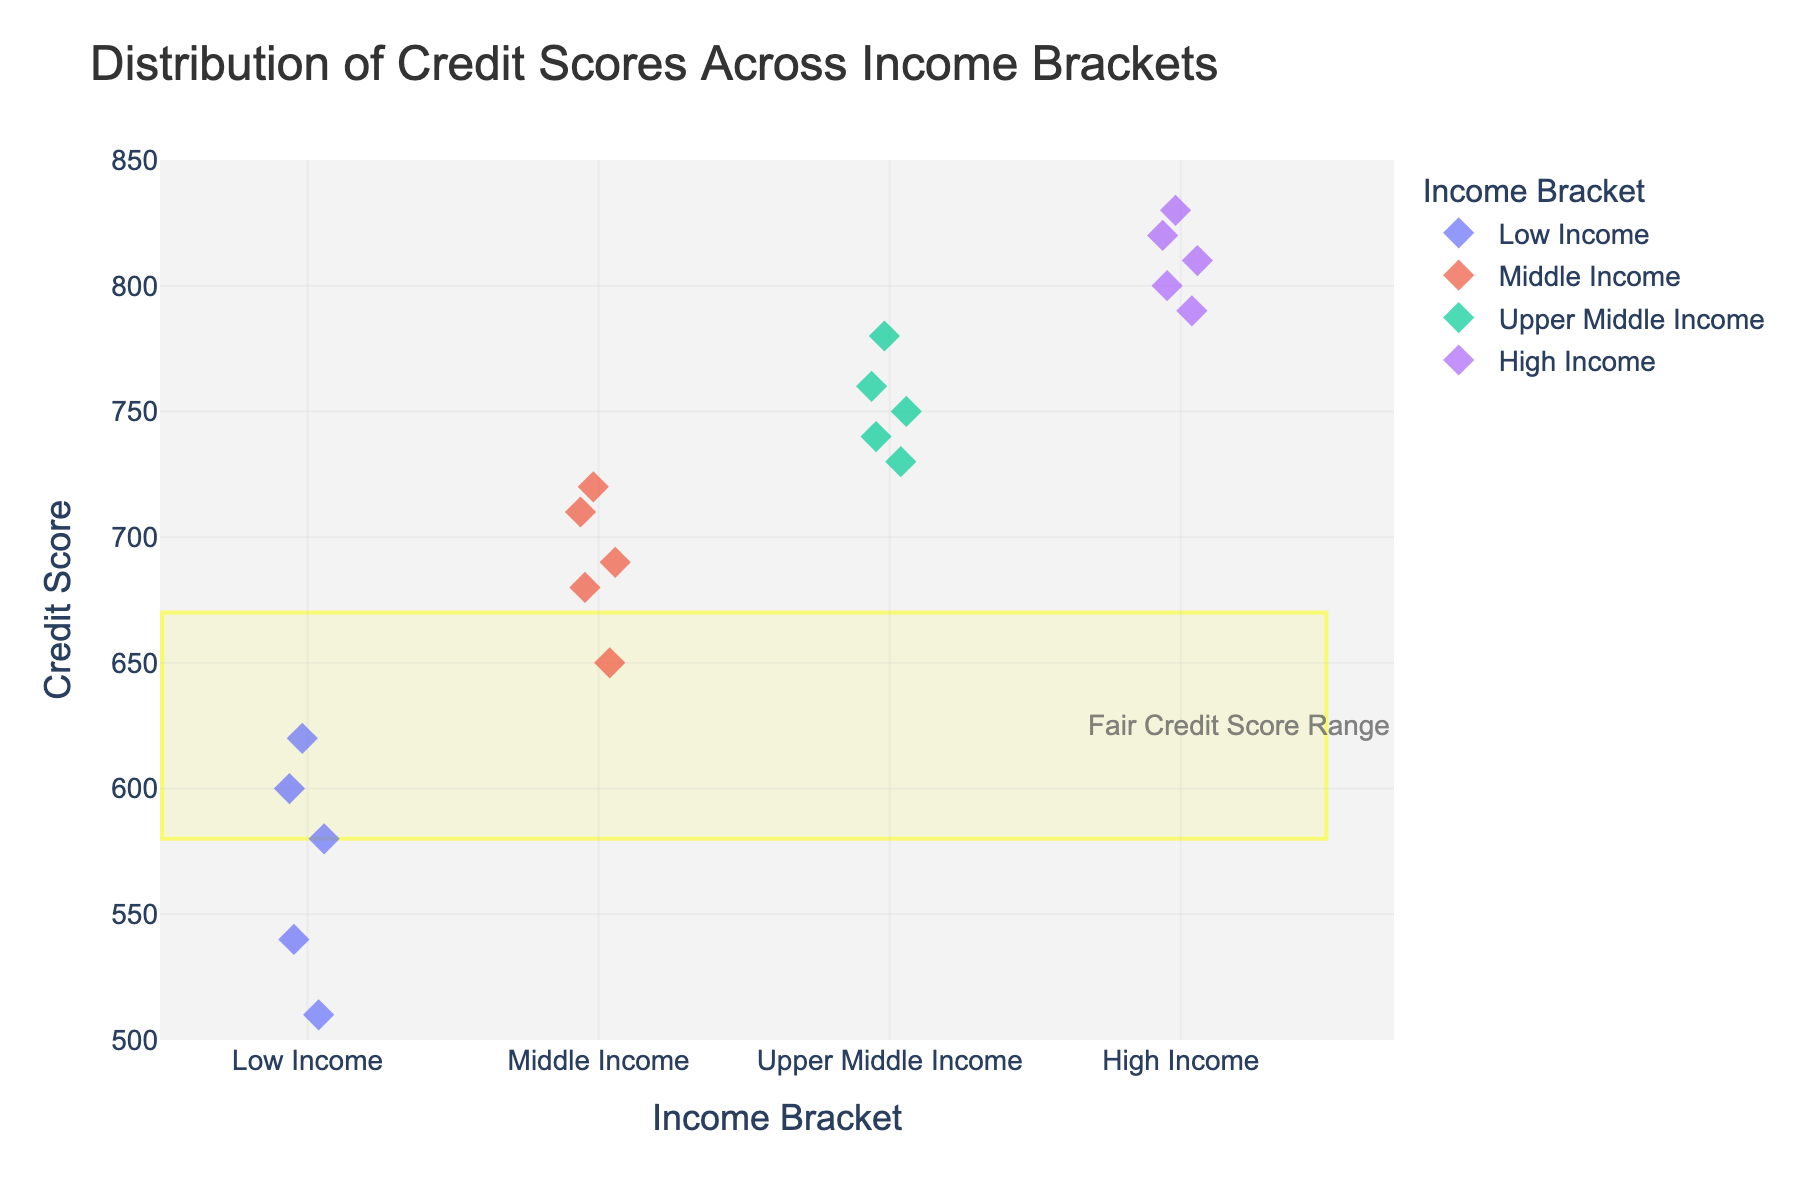What's the title of the figure? The title of the figure is displayed at the top and summarizes the content of the plot. In this case, the title reads "Distribution of Credit Scores Across Income Brackets."
Answer: Distribution of Credit Scores Across Income Brackets How are the income brackets represented in the strip plot? The income brackets are represented as different categories along the x-axis. They are "Low Income," "Middle Income," "Upper Middle Income," and "High Income."
Answer: Categories along the x-axis Which income bracket has the most densely clustered credit scores? By observing the position and clustering of the data points, "Middle Income" has the most clustered credit scores with many points close together.
Answer: Middle Income What is the range of credit scores in the "Low Income" bracket? The lowest and highest points in the "Low Income" bracket can be noted. They range from 510 to 620.
Answer: 510 to 620 In which income bracket is the "fair" credit score range prominently concentrated? The rectangular shape highlights the "fair" credit score range (580 to 670). Most points in this range are in the "Low Income" bracket.
Answer: Low Income How many data points fall in the "High Income" category? Count the number of data points that fall under the "High Income" category on the x-axis. There are 5 data points.
Answer: 5 How does the median credit score of "Middle Income" compare to that of "Upper Middle Income"? The median can be estimated visually by identifying the middle point of each income bracket. "Middle Income" has a median around 690 or 700, while "Upper Middle Income" has a median around 750.
Answer: Upper Middle Income is higher What is the general trend in credit scores as income brackets increase? Observing the distribution from "Low Income" to "High Income," there is an upward trend in credit scores with higher income brackets.
Answer: Upward trend What visual markers are used to represent data points in this strip plot? The visual markers used are diamond-shaped symbols with some opacity and jitter.
Answer: Diamond-shaped symbols Does the "Upper Middle Income" bracket contain any points within the "fair" credit score range? By comparing the credit score points in "Upper Middle Income" with the highlighted "fair" range, no points fall within 580 to 670.
Answer: No 